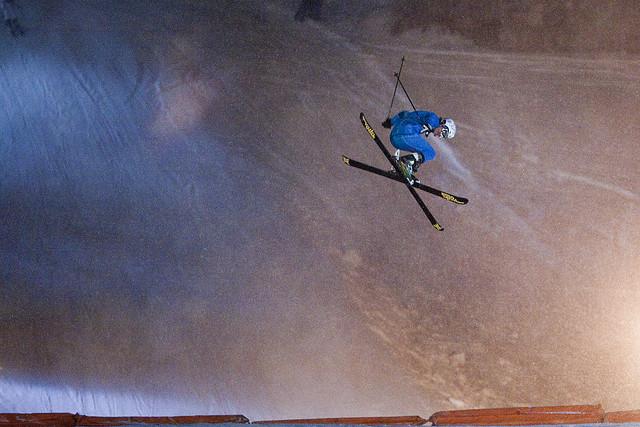What color is the ski suit?
Answer briefly. Blue. What letter do the two skis resemble?
Answer briefly. X. Is the man jumping?
Be succinct. Yes. 